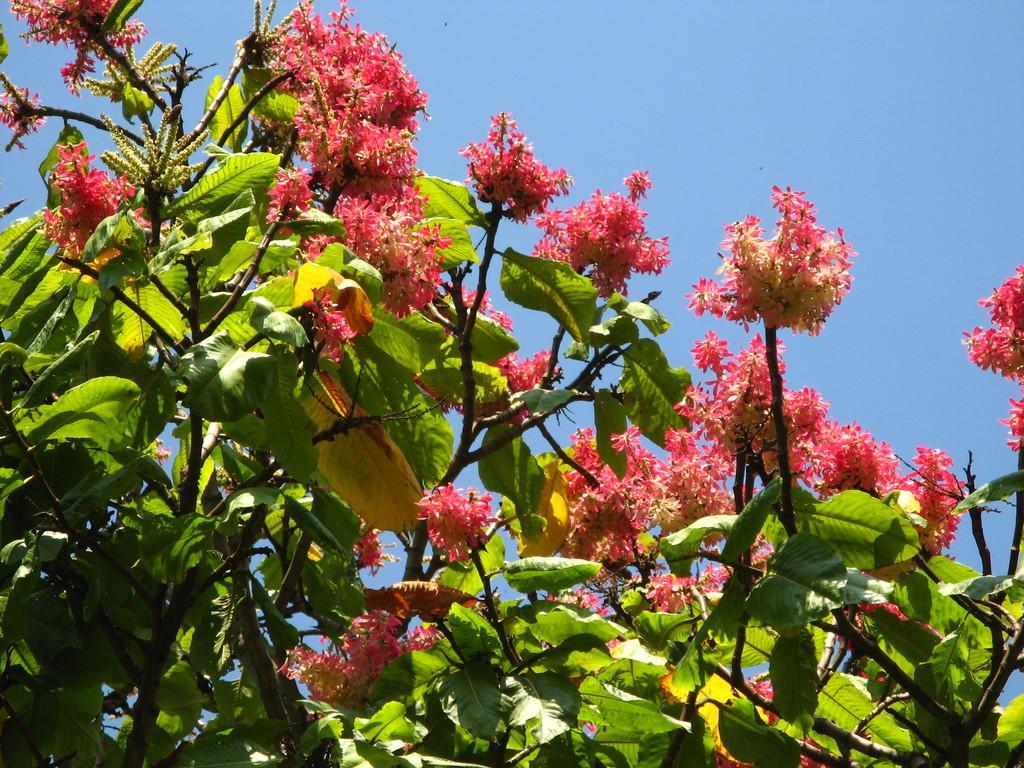How would you summarize this image in a sentence or two? In the foreground of the picture there are flowers, leaves and stems of a tree. Sky is clear and it is sunny. 